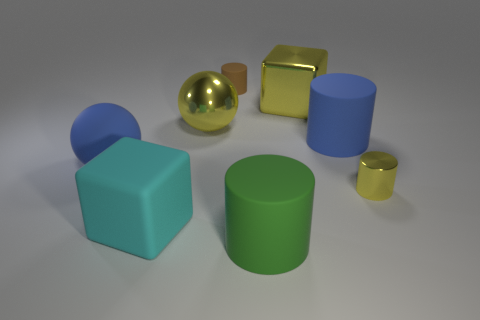What material is the cylinder that is both left of the large yellow metallic block and in front of the tiny matte cylinder?
Provide a short and direct response. Rubber. Are there any other things that have the same size as the rubber sphere?
Your answer should be compact. Yes. Do the matte ball and the rubber cube have the same color?
Offer a very short reply. No. What shape is the large shiny object that is the same color as the shiny sphere?
Offer a very short reply. Cube. How many big things are the same shape as the small matte object?
Keep it short and to the point. 2. What size is the cyan block that is made of the same material as the blue cylinder?
Offer a very short reply. Large. Does the yellow ball have the same size as the cyan thing?
Keep it short and to the point. Yes. Are any tiny gray cylinders visible?
Your answer should be very brief. No. There is a metallic sphere that is the same color as the tiny metallic object; what is its size?
Provide a succinct answer. Large. There is a block to the right of the small object that is on the left side of the thing that is in front of the cyan object; what is its size?
Your answer should be compact. Large. 